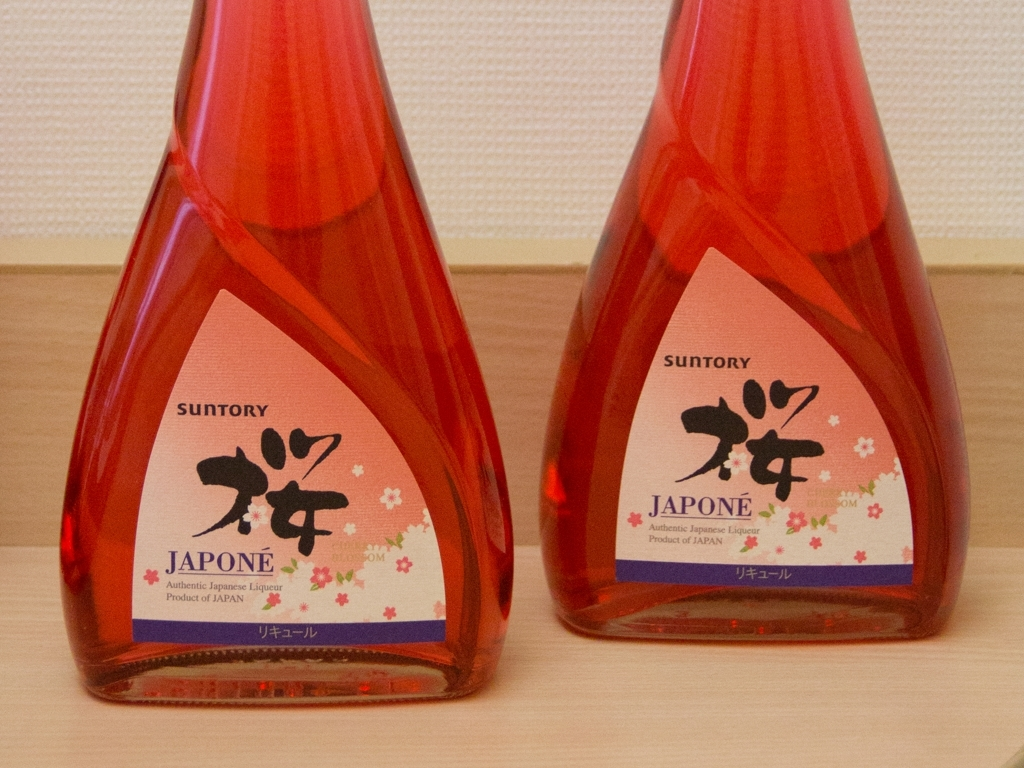What can we infer about the brand from the packaging? The packaging suggests that the brand values tradition and authenticity, as implied by the word 'Authentic' on the labels. The use of Japanese calligraphy, cherry blossoms, and the name 'JAPONE' all emphasize its Japanese origins and cultural ties. Does the color of the bottle have any significance? While the exact significance can vary, red in Japanese culture is often associated with good fortune and happiness. It's a color that's also prominent in traditional festivals and celebrations, suggesting that the liqueur might be enjoyed on special occasions. 